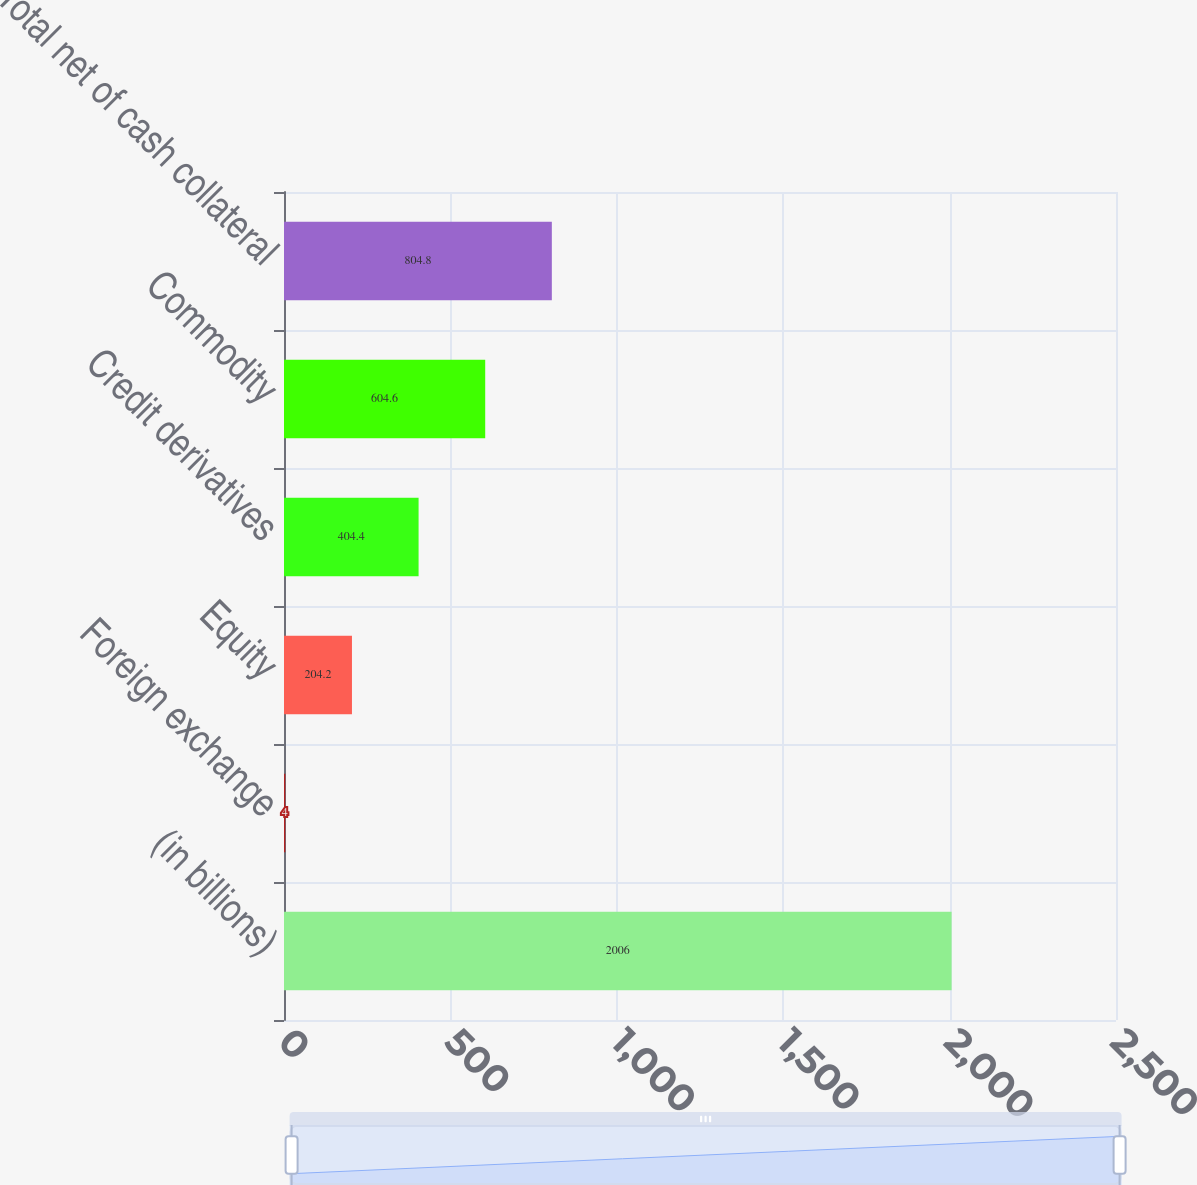Convert chart to OTSL. <chart><loc_0><loc_0><loc_500><loc_500><bar_chart><fcel>(in billions)<fcel>Foreign exchange<fcel>Equity<fcel>Credit derivatives<fcel>Commodity<fcel>Total net of cash collateral<nl><fcel>2006<fcel>4<fcel>204.2<fcel>404.4<fcel>604.6<fcel>804.8<nl></chart> 